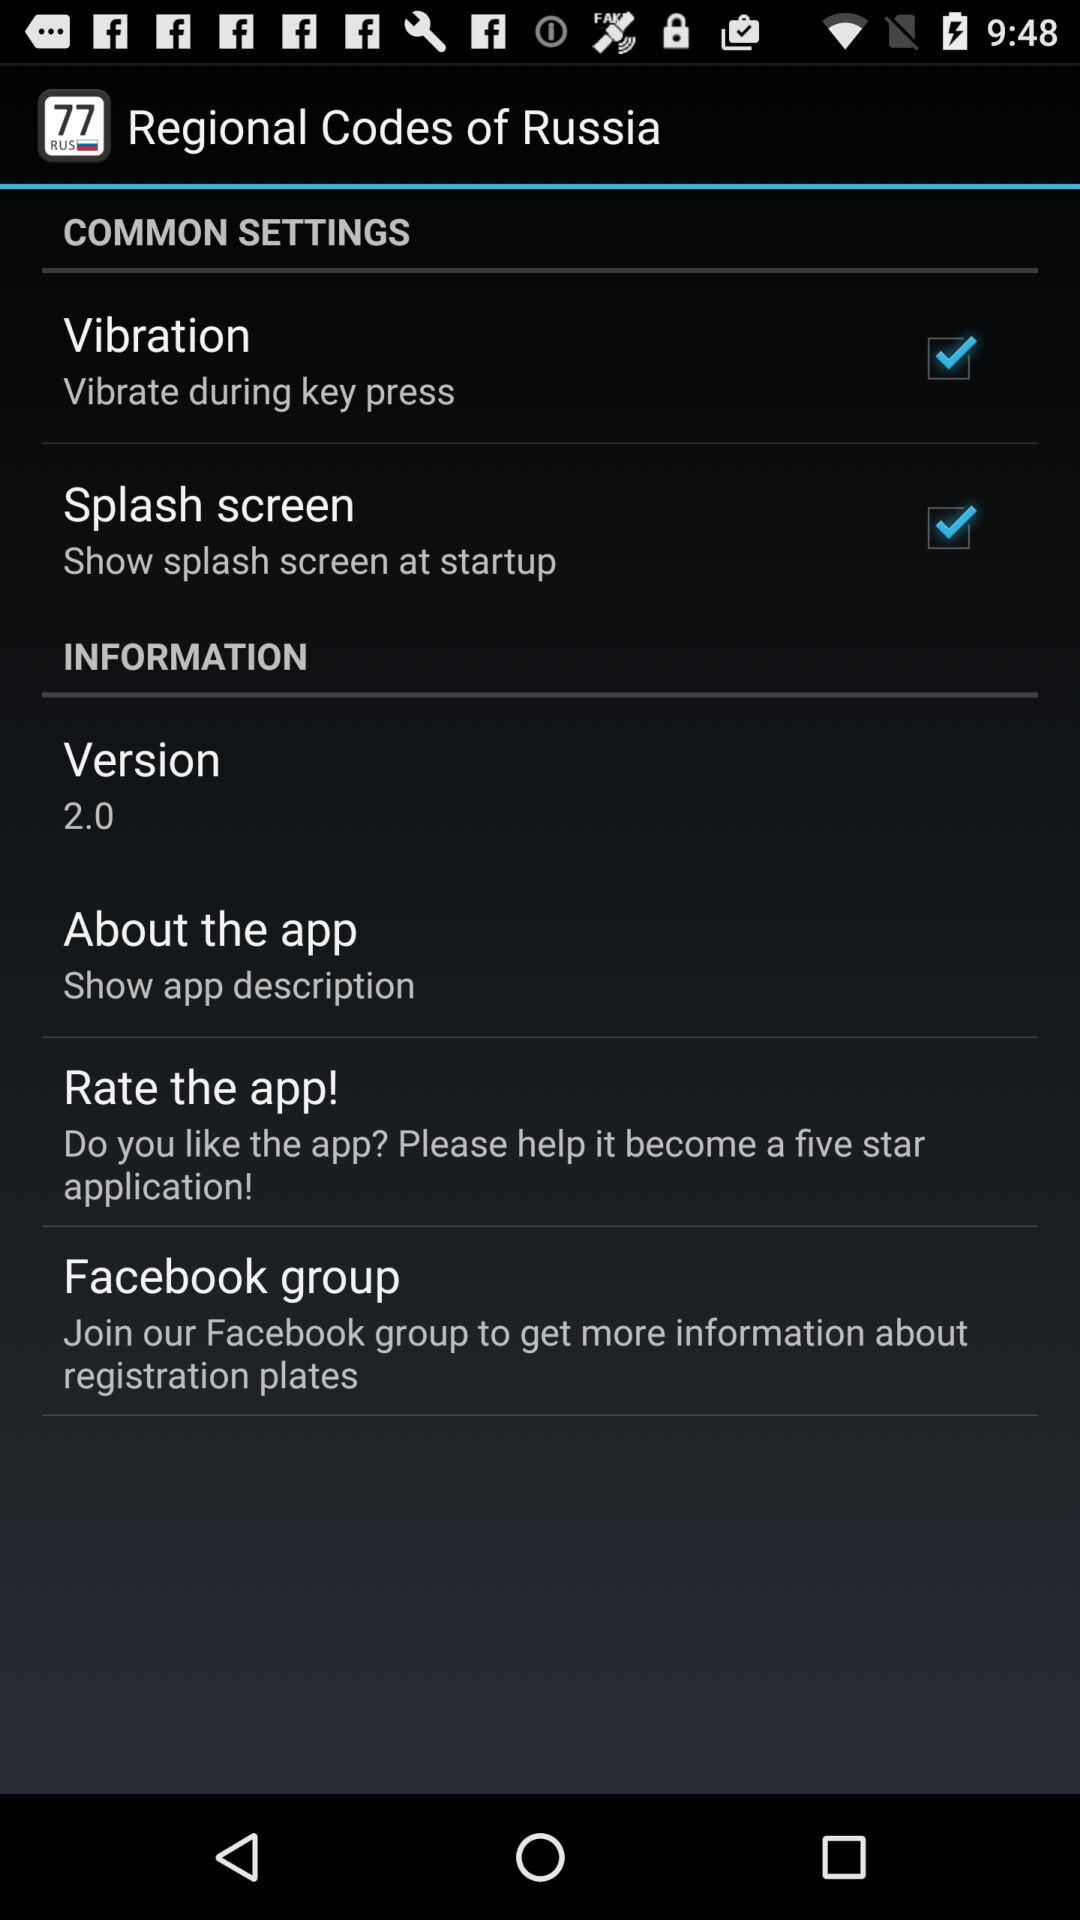How many stars does the application have?
When the provided information is insufficient, respond with <no answer>. <no answer> 